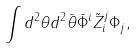<formula> <loc_0><loc_0><loc_500><loc_500>\int d ^ { 2 } \theta d ^ { 2 } \bar { \theta } \bar { \Phi } ^ { i } \tilde { Z } _ { i } ^ { j } \Phi _ { j } ,</formula> 